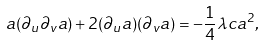Convert formula to latex. <formula><loc_0><loc_0><loc_500><loc_500>a ( \partial _ { u } \partial _ { v } a ) + 2 ( \partial _ { u } a ) ( \partial _ { v } a ) = - \frac { 1 } { 4 } \lambda c a ^ { 2 } ,</formula> 